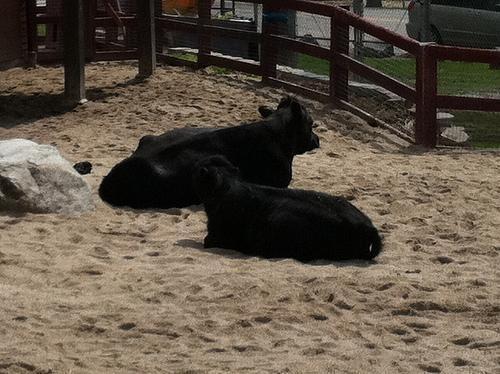How many cows are shown?
Give a very brief answer. 2. 